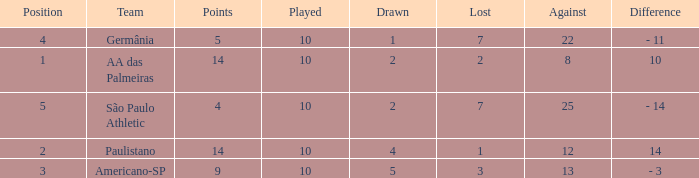What is the sum of Against when the lost is more than 7? None. 